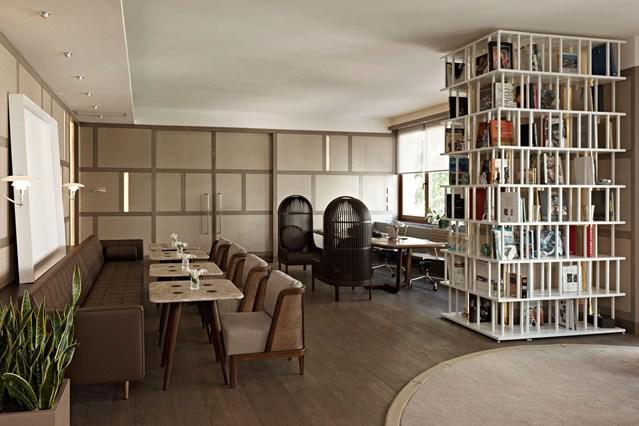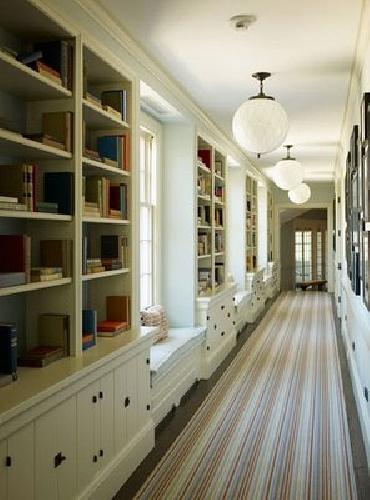The first image is the image on the left, the second image is the image on the right. For the images shown, is this caption "In each image, a wide white shelving unit is placed perpendicular to a wall to create a room divider." true? Answer yes or no. No. The first image is the image on the left, the second image is the image on the right. For the images shown, is this caption "One of the bookshelves has decorative items on top as well as on the shelves." true? Answer yes or no. No. 